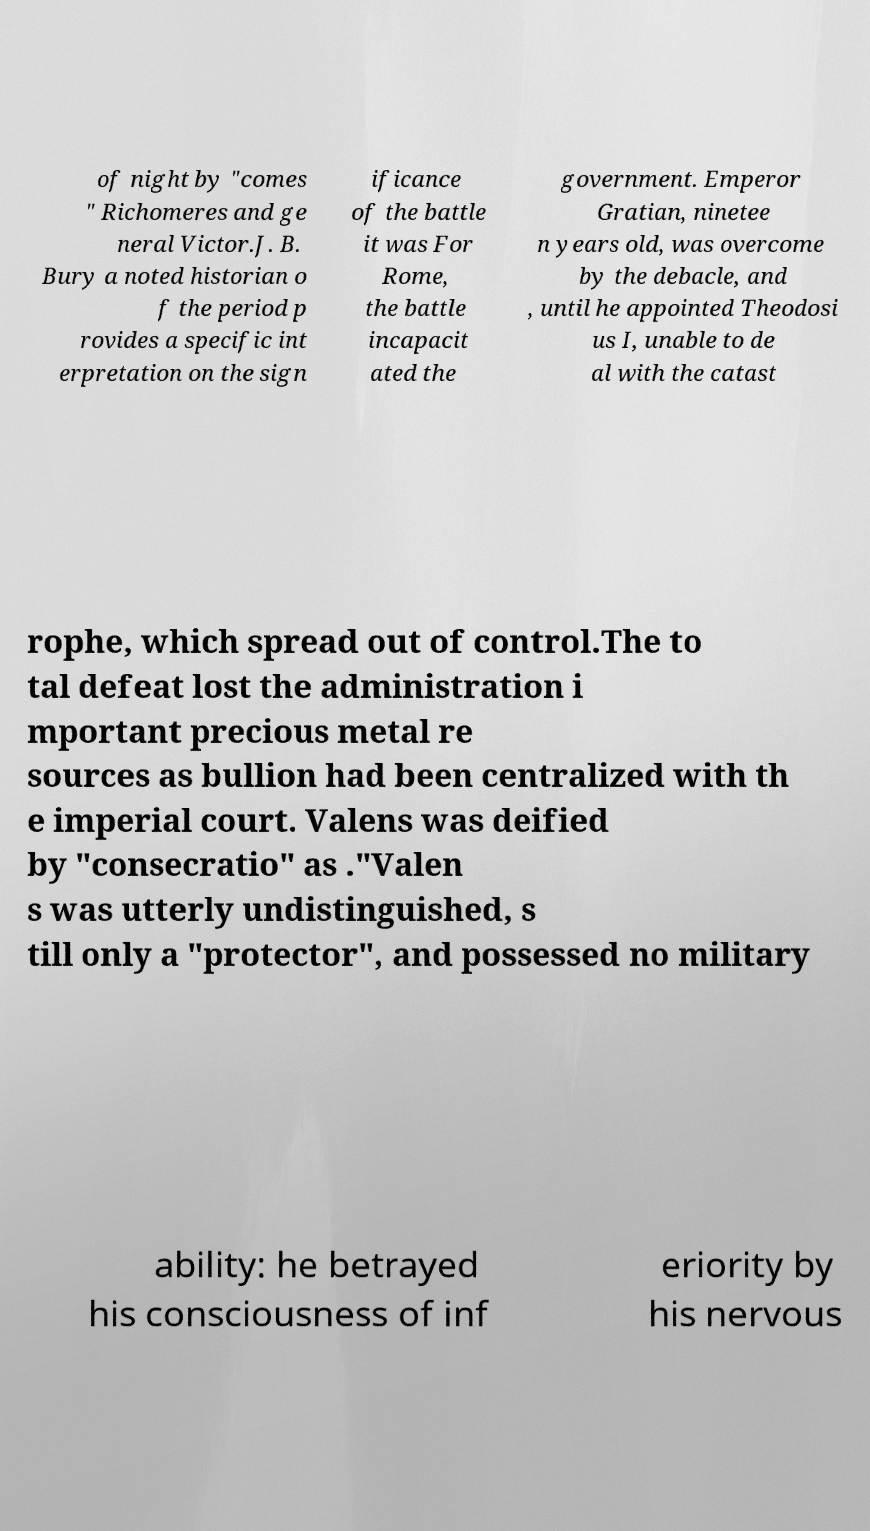What messages or text are displayed in this image? I need them in a readable, typed format. of night by "comes " Richomeres and ge neral Victor.J. B. Bury a noted historian o f the period p rovides a specific int erpretation on the sign ificance of the battle it was For Rome, the battle incapacit ated the government. Emperor Gratian, ninetee n years old, was overcome by the debacle, and , until he appointed Theodosi us I, unable to de al with the catast rophe, which spread out of control.The to tal defeat lost the administration i mportant precious metal re sources as bullion had been centralized with th e imperial court. Valens was deified by "consecratio" as ."Valen s was utterly undistinguished, s till only a "protector", and possessed no military ability: he betrayed his consciousness of inf eriority by his nervous 